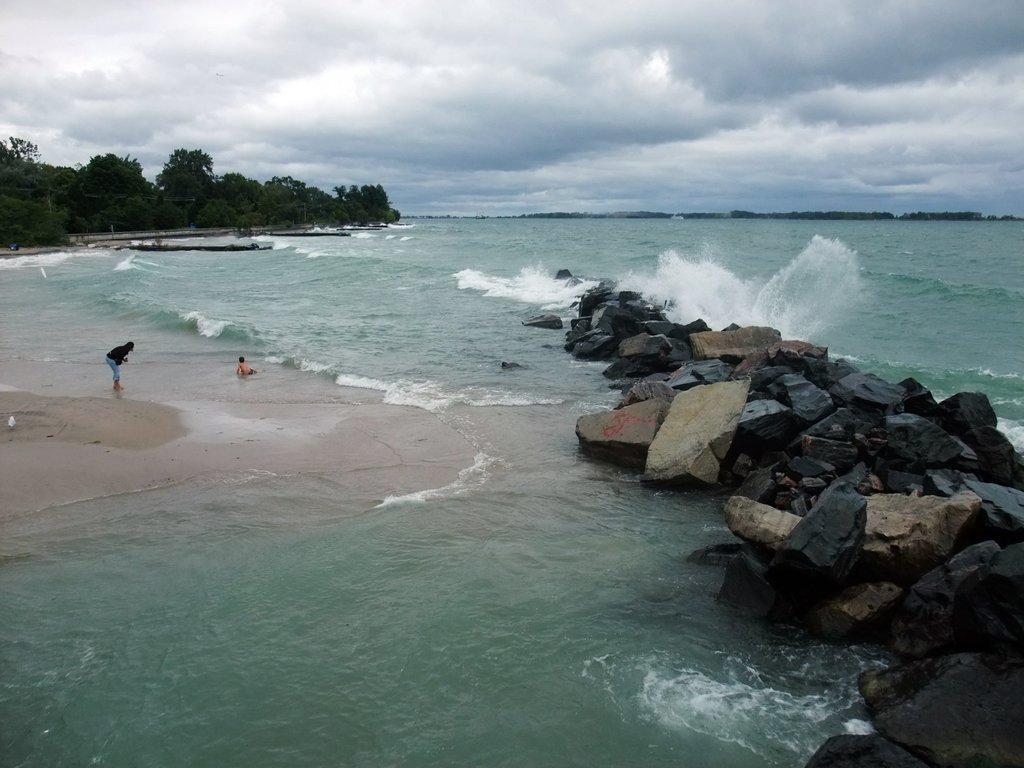Could you give a brief overview of what you see in this image? The image is taken near a beach. In the foreground of the picture there are stones. In the foreground of the picture there is a water body. On the left there is a woman and a kid. In the background there are trees. Sky is cloudy. 